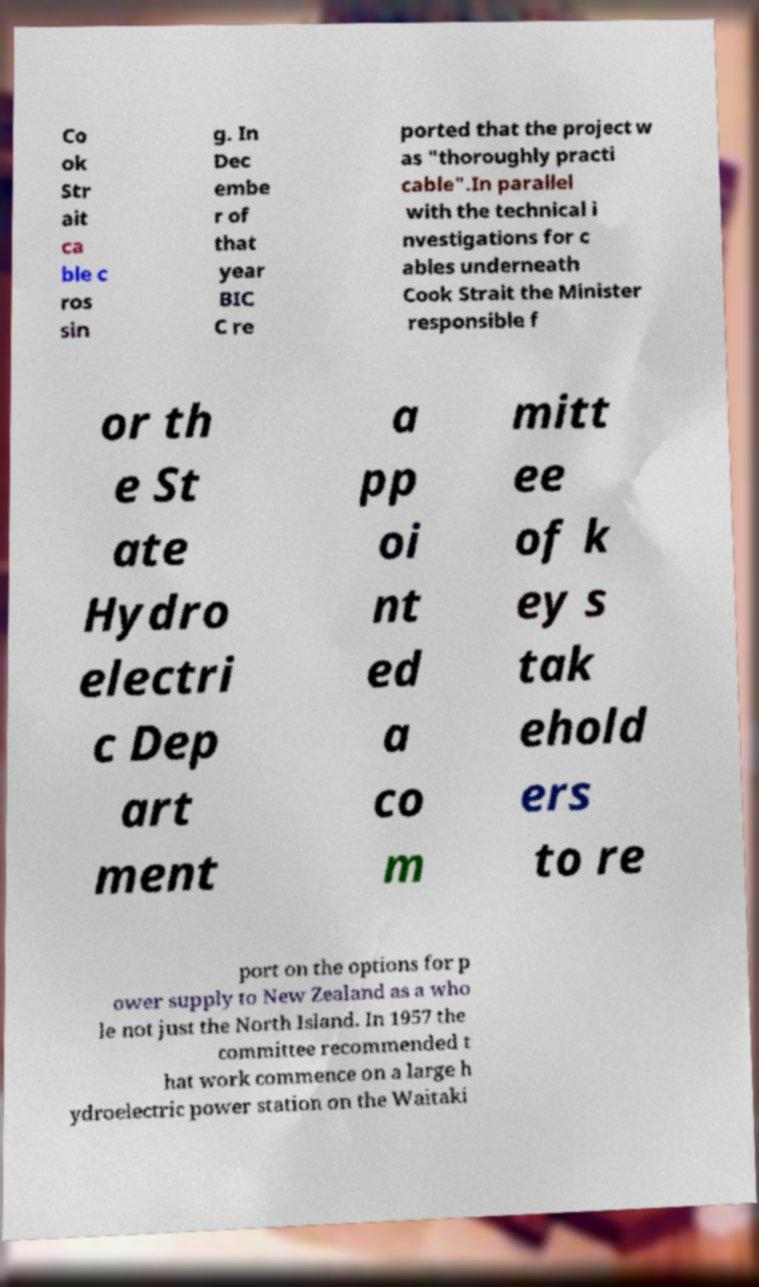Can you accurately transcribe the text from the provided image for me? Co ok Str ait ca ble c ros sin g. In Dec embe r of that year BIC C re ported that the project w as "thoroughly practi cable".In parallel with the technical i nvestigations for c ables underneath Cook Strait the Minister responsible f or th e St ate Hydro electri c Dep art ment a pp oi nt ed a co m mitt ee of k ey s tak ehold ers to re port on the options for p ower supply to New Zealand as a who le not just the North Island. In 1957 the committee recommended t hat work commence on a large h ydroelectric power station on the Waitaki 